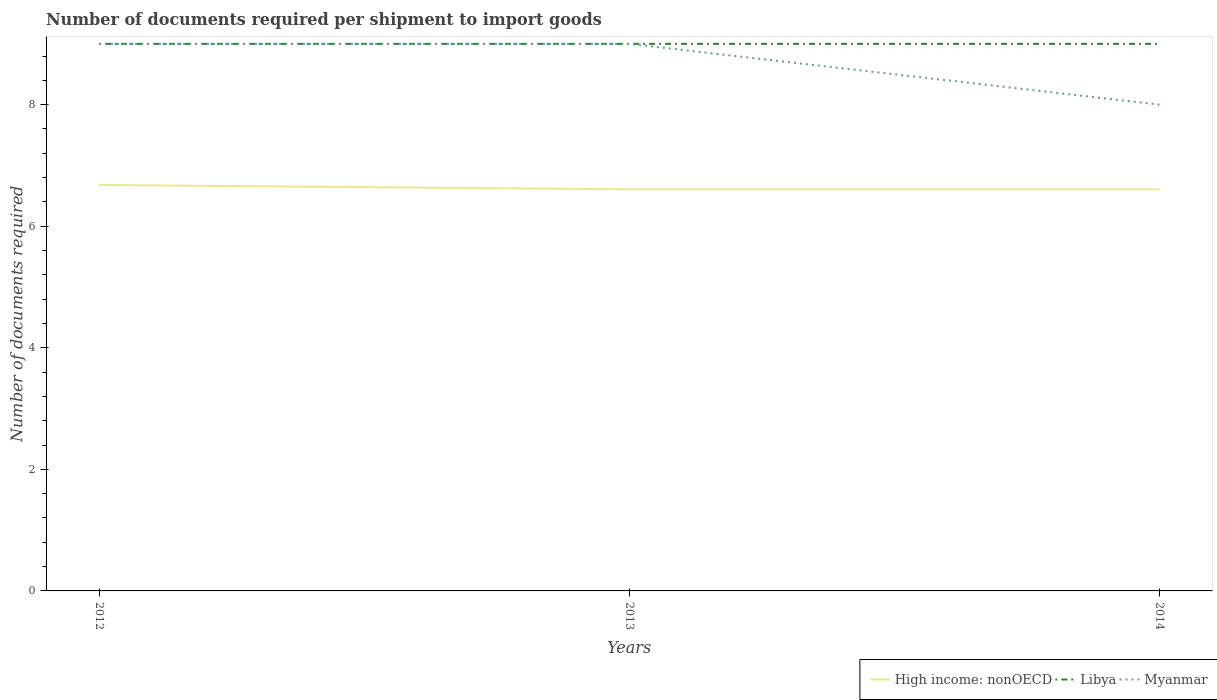How many different coloured lines are there?
Provide a short and direct response. 3. Across all years, what is the maximum number of documents required per shipment to import goods in High income: nonOECD?
Keep it short and to the point. 6.61. In which year was the number of documents required per shipment to import goods in Myanmar maximum?
Keep it short and to the point. 2014. What is the total number of documents required per shipment to import goods in Libya in the graph?
Provide a succinct answer. 0. What is the difference between the highest and the second highest number of documents required per shipment to import goods in Libya?
Your answer should be very brief. 0. How many years are there in the graph?
Your response must be concise. 3. What is the difference between two consecutive major ticks on the Y-axis?
Provide a succinct answer. 2. Are the values on the major ticks of Y-axis written in scientific E-notation?
Keep it short and to the point. No. Does the graph contain any zero values?
Ensure brevity in your answer.  No. Does the graph contain grids?
Your answer should be very brief. No. Where does the legend appear in the graph?
Your answer should be compact. Bottom right. How many legend labels are there?
Offer a very short reply. 3. What is the title of the graph?
Your answer should be compact. Number of documents required per shipment to import goods. What is the label or title of the Y-axis?
Keep it short and to the point. Number of documents required. What is the Number of documents required in High income: nonOECD in 2012?
Give a very brief answer. 6.68. What is the Number of documents required of Libya in 2012?
Offer a very short reply. 9. What is the Number of documents required in High income: nonOECD in 2013?
Your response must be concise. 6.61. What is the Number of documents required of Libya in 2013?
Offer a very short reply. 9. What is the Number of documents required of High income: nonOECD in 2014?
Your answer should be compact. 6.61. What is the Number of documents required of Libya in 2014?
Your answer should be very brief. 9. Across all years, what is the maximum Number of documents required of High income: nonOECD?
Your answer should be very brief. 6.68. Across all years, what is the maximum Number of documents required in Libya?
Your answer should be compact. 9. Across all years, what is the maximum Number of documents required of Myanmar?
Offer a terse response. 9. Across all years, what is the minimum Number of documents required in High income: nonOECD?
Provide a succinct answer. 6.61. Across all years, what is the minimum Number of documents required of Libya?
Your response must be concise. 9. Across all years, what is the minimum Number of documents required of Myanmar?
Your answer should be very brief. 8. What is the total Number of documents required of High income: nonOECD in the graph?
Ensure brevity in your answer.  19.89. What is the total Number of documents required of Myanmar in the graph?
Your answer should be very brief. 26. What is the difference between the Number of documents required of High income: nonOECD in 2012 and that in 2013?
Give a very brief answer. 0.07. What is the difference between the Number of documents required in High income: nonOECD in 2012 and that in 2014?
Provide a short and direct response. 0.07. What is the difference between the Number of documents required of Myanmar in 2012 and that in 2014?
Your answer should be compact. 1. What is the difference between the Number of documents required of High income: nonOECD in 2013 and that in 2014?
Your response must be concise. 0. What is the difference between the Number of documents required in High income: nonOECD in 2012 and the Number of documents required in Libya in 2013?
Give a very brief answer. -2.32. What is the difference between the Number of documents required in High income: nonOECD in 2012 and the Number of documents required in Myanmar in 2013?
Ensure brevity in your answer.  -2.32. What is the difference between the Number of documents required of Libya in 2012 and the Number of documents required of Myanmar in 2013?
Ensure brevity in your answer.  0. What is the difference between the Number of documents required of High income: nonOECD in 2012 and the Number of documents required of Libya in 2014?
Keep it short and to the point. -2.32. What is the difference between the Number of documents required in High income: nonOECD in 2012 and the Number of documents required in Myanmar in 2014?
Make the answer very short. -1.32. What is the difference between the Number of documents required of High income: nonOECD in 2013 and the Number of documents required of Libya in 2014?
Give a very brief answer. -2.39. What is the difference between the Number of documents required of High income: nonOECD in 2013 and the Number of documents required of Myanmar in 2014?
Offer a terse response. -1.39. What is the average Number of documents required in High income: nonOECD per year?
Your response must be concise. 6.63. What is the average Number of documents required of Myanmar per year?
Make the answer very short. 8.67. In the year 2012, what is the difference between the Number of documents required of High income: nonOECD and Number of documents required of Libya?
Offer a terse response. -2.32. In the year 2012, what is the difference between the Number of documents required of High income: nonOECD and Number of documents required of Myanmar?
Keep it short and to the point. -2.32. In the year 2012, what is the difference between the Number of documents required of Libya and Number of documents required of Myanmar?
Provide a short and direct response. 0. In the year 2013, what is the difference between the Number of documents required in High income: nonOECD and Number of documents required in Libya?
Provide a succinct answer. -2.39. In the year 2013, what is the difference between the Number of documents required of High income: nonOECD and Number of documents required of Myanmar?
Your answer should be compact. -2.39. In the year 2014, what is the difference between the Number of documents required in High income: nonOECD and Number of documents required in Libya?
Give a very brief answer. -2.39. In the year 2014, what is the difference between the Number of documents required in High income: nonOECD and Number of documents required in Myanmar?
Offer a very short reply. -1.39. What is the ratio of the Number of documents required of High income: nonOECD in 2012 to that in 2013?
Your answer should be very brief. 1.01. What is the ratio of the Number of documents required of High income: nonOECD in 2012 to that in 2014?
Keep it short and to the point. 1.01. What is the ratio of the Number of documents required in High income: nonOECD in 2013 to that in 2014?
Your answer should be very brief. 1. What is the difference between the highest and the second highest Number of documents required of High income: nonOECD?
Provide a short and direct response. 0.07. What is the difference between the highest and the second highest Number of documents required in Libya?
Offer a very short reply. 0. What is the difference between the highest and the lowest Number of documents required in High income: nonOECD?
Provide a short and direct response. 0.07. What is the difference between the highest and the lowest Number of documents required of Libya?
Make the answer very short. 0. What is the difference between the highest and the lowest Number of documents required of Myanmar?
Provide a short and direct response. 1. 